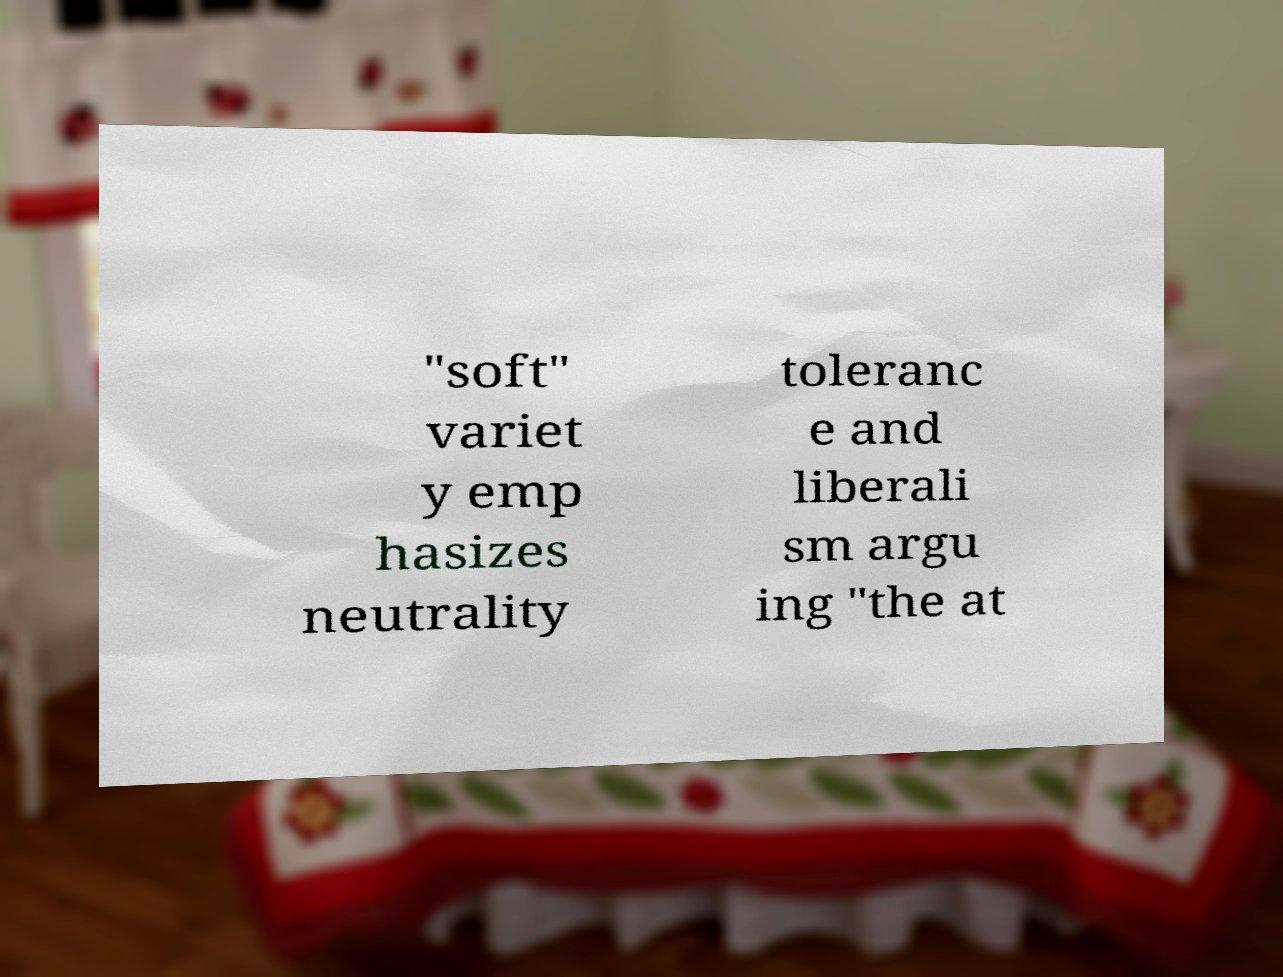There's text embedded in this image that I need extracted. Can you transcribe it verbatim? "soft" variet y emp hasizes neutrality toleranc e and liberali sm argu ing "the at 